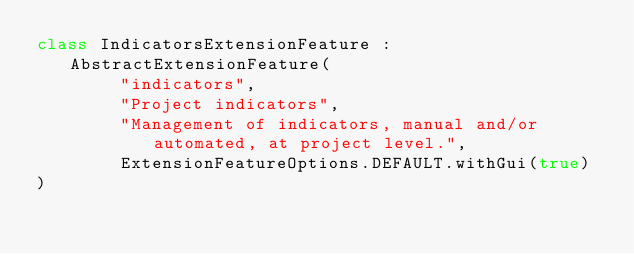<code> <loc_0><loc_0><loc_500><loc_500><_Kotlin_>class IndicatorsExtensionFeature : AbstractExtensionFeature(
        "indicators",
        "Project indicators",
        "Management of indicators, manual and/or automated, at project level.",
        ExtensionFeatureOptions.DEFAULT.withGui(true)
)
</code> 